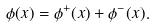Convert formula to latex. <formula><loc_0><loc_0><loc_500><loc_500>\phi ( x ) = \phi ^ { + } ( x ) + \phi ^ { - } ( x ) .</formula> 